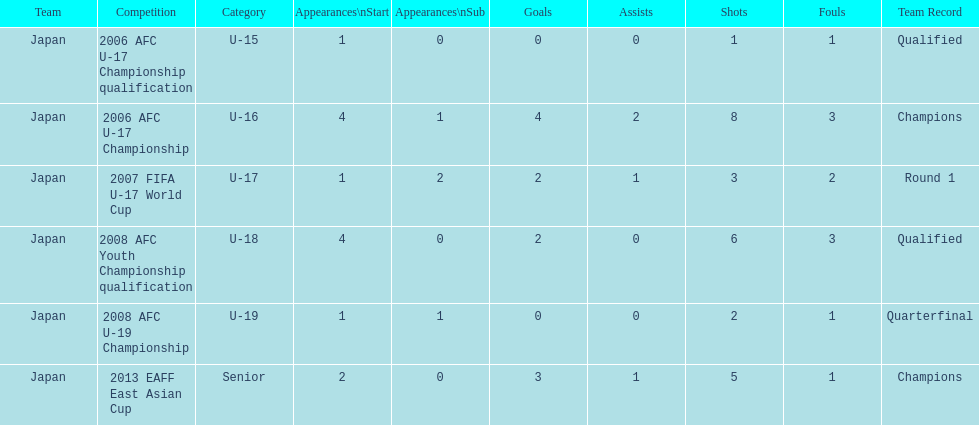Yoichiro kakitani scored above 2 goals in how many major competitions? 2. 